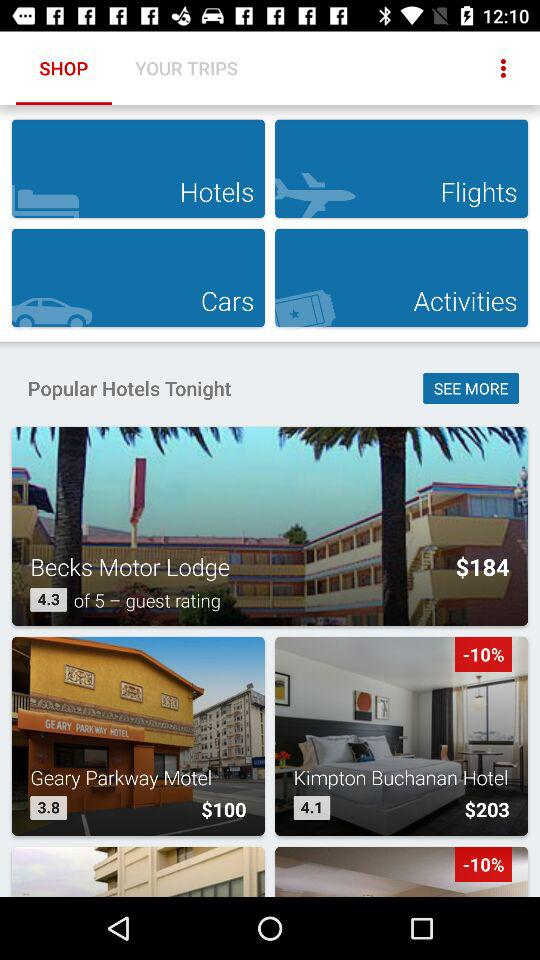What is the booking price of a room in the "Kimpton Buchanan Hotel"? The booking price of a room in the "Kimpton Buchanan Hotel" is $203. 